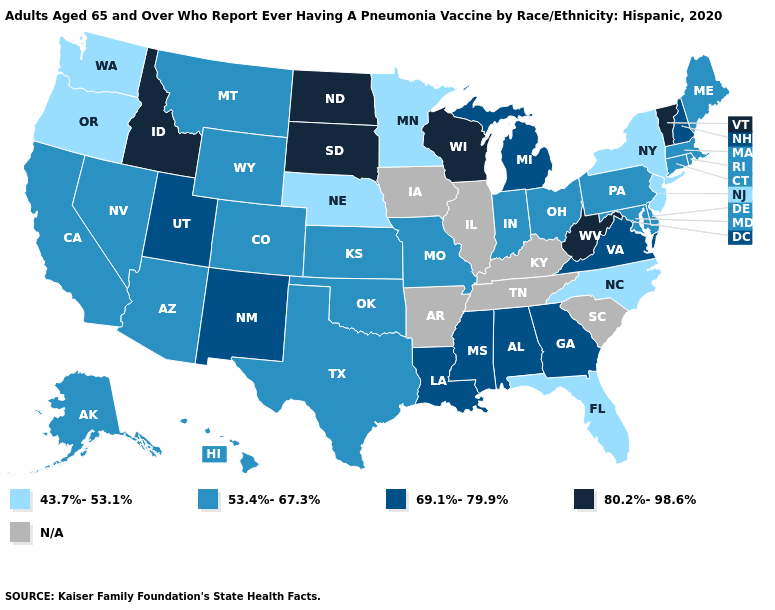Which states have the lowest value in the West?
Keep it brief. Oregon, Washington. Is the legend a continuous bar?
Keep it brief. No. Among the states that border Missouri , which have the lowest value?
Give a very brief answer. Nebraska. Among the states that border Georgia , does North Carolina have the highest value?
Write a very short answer. No. Which states have the highest value in the USA?
Short answer required. Idaho, North Dakota, South Dakota, Vermont, West Virginia, Wisconsin. What is the value of Maine?
Keep it brief. 53.4%-67.3%. Name the states that have a value in the range 69.1%-79.9%?
Keep it brief. Alabama, Georgia, Louisiana, Michigan, Mississippi, New Hampshire, New Mexico, Utah, Virginia. Does the first symbol in the legend represent the smallest category?
Keep it brief. Yes. What is the value of South Carolina?
Answer briefly. N/A. Name the states that have a value in the range 43.7%-53.1%?
Be succinct. Florida, Minnesota, Nebraska, New Jersey, New York, North Carolina, Oregon, Washington. What is the value of New Mexico?
Keep it brief. 69.1%-79.9%. Which states have the highest value in the USA?
Be succinct. Idaho, North Dakota, South Dakota, Vermont, West Virginia, Wisconsin. Does West Virginia have the lowest value in the South?
Concise answer only. No. What is the lowest value in the MidWest?
Give a very brief answer. 43.7%-53.1%. 